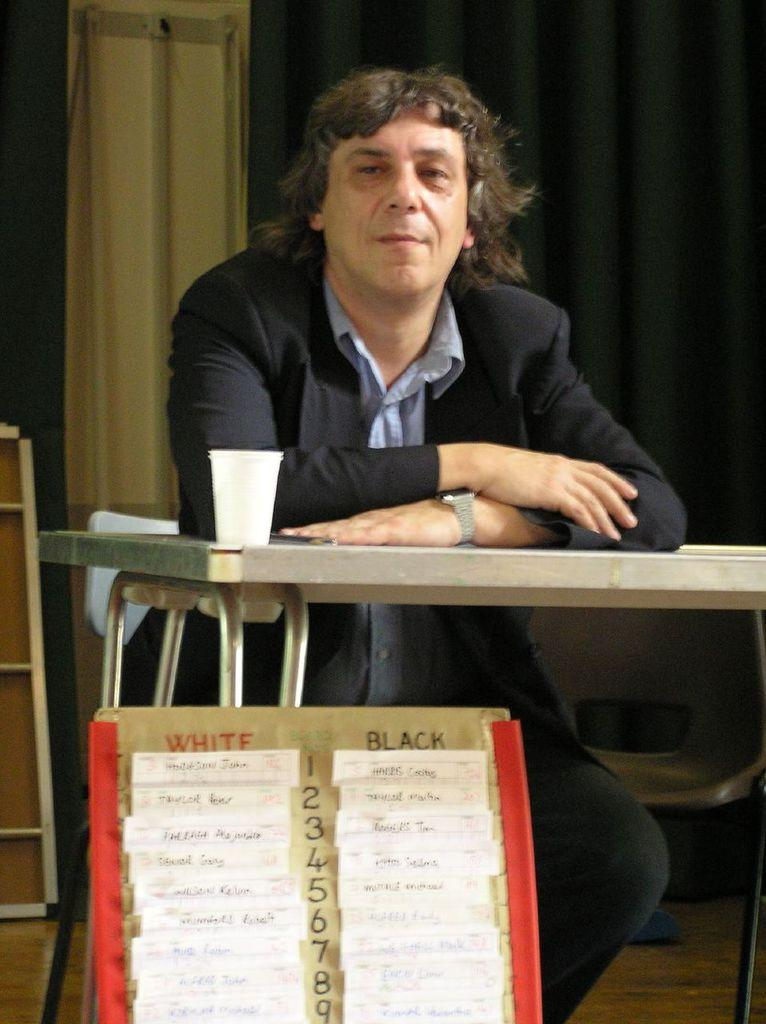What is the main subject of the image? There is a man in the image. What is in front of the man? There is a table and a board in front of the man. What is on the table? There is a glass on the table. What can be seen in the background of the image? There is a chair, a curtain, and a board in the background of the image. What type of spy equipment can be seen on the board in the background of the image? There is no spy equipment present in the image; the board in the background does not have any visible objects related to spying. 